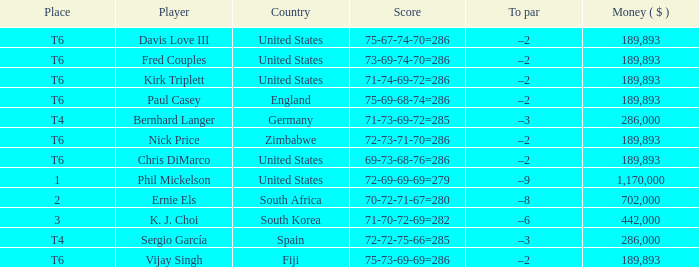What is the most money ($) when the score is 71-74-69-72=286? 189893.0. 